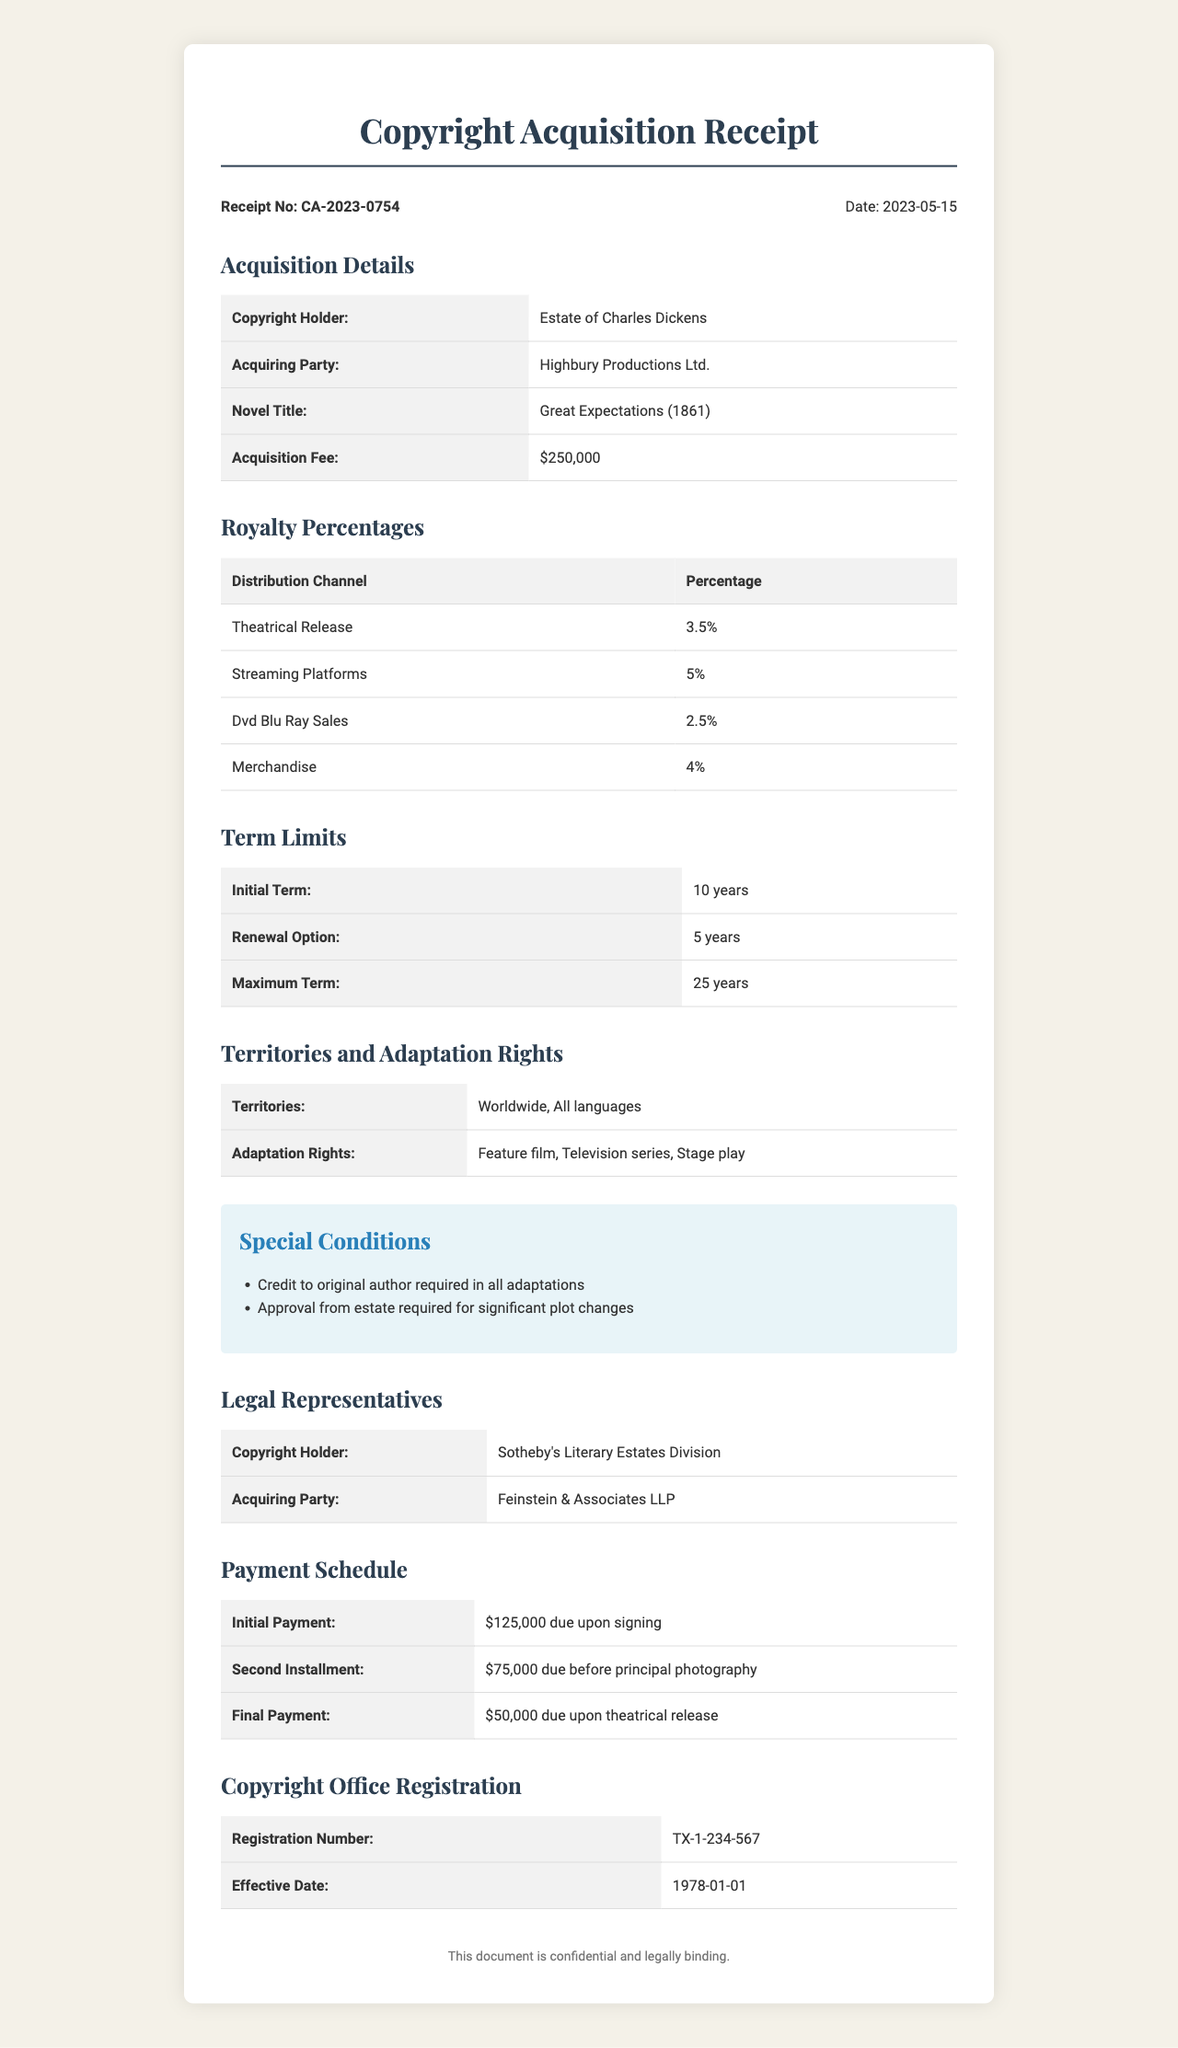What is the receipt number? The receipt number is specified at the top of the document and identifies this particular transaction.
Answer: CA-2023-0754 Who is the copyright holder? The document indicates the holder of the rights to the novel for which the receipt was issued.
Answer: Estate of Charles Dickens What is the acquisition fee? The acquisition fee is a specific monetary amount mentioned in the document for obtaining the rights to the novel.
Answer: $250,000 What is the initial term of the rights? The initial term represents how long the acquiring party holds the rights before any renewal option can be exercised.
Answer: 10 years What percentage is allocated for streaming platforms? This percentage details how much revenue from streaming platforms will be owed as royalties.
Answer: 5% What is the maximum term for the rights? The maximum term indicates the longest duration for which the rights can be secured through renewal.
Answer: 25 years What payment is due upon signing? This details the sum of money that must be paid immediately after the contract is signed.
Answer: $125,000 What adaptation rights are included? This specifies the types of adaptations permitted for the novel as outlined in the receipt.
Answer: Feature film, Television series, Stage play What special condition is required regarding the original author? This condition outlines a specific requirement that must be adhered to in all adaptations.
Answer: Credit to original author required in all adaptations 